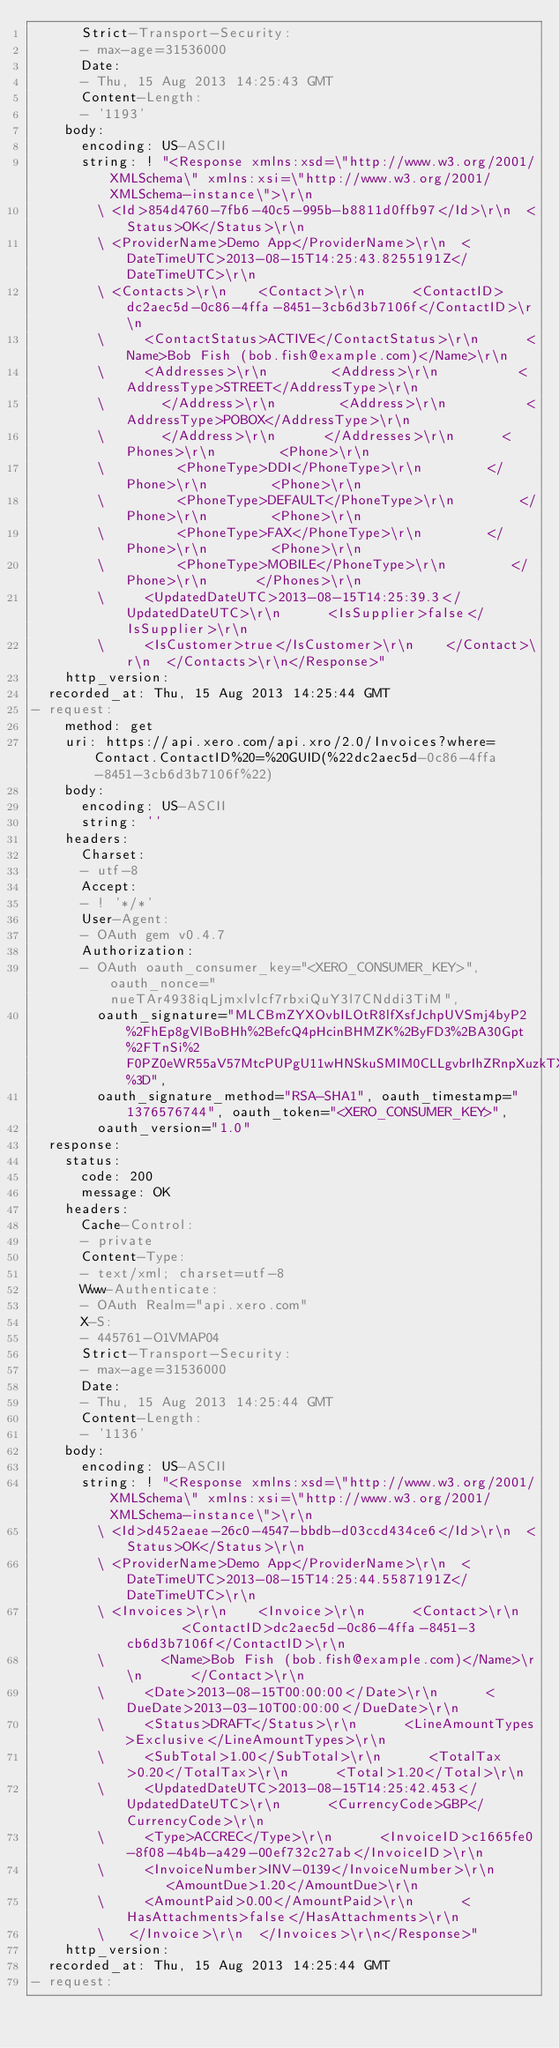Convert code to text. <code><loc_0><loc_0><loc_500><loc_500><_YAML_>      Strict-Transport-Security:
      - max-age=31536000
      Date:
      - Thu, 15 Aug 2013 14:25:43 GMT
      Content-Length:
      - '1193'
    body:
      encoding: US-ASCII
      string: ! "<Response xmlns:xsd=\"http://www.w3.org/2001/XMLSchema\" xmlns:xsi=\"http://www.w3.org/2001/XMLSchema-instance\">\r\n
        \ <Id>854d4760-7fb6-40c5-995b-b8811d0ffb97</Id>\r\n  <Status>OK</Status>\r\n
        \ <ProviderName>Demo App</ProviderName>\r\n  <DateTimeUTC>2013-08-15T14:25:43.8255191Z</DateTimeUTC>\r\n
        \ <Contacts>\r\n    <Contact>\r\n      <ContactID>dc2aec5d-0c86-4ffa-8451-3cb6d3b7106f</ContactID>\r\n
        \     <ContactStatus>ACTIVE</ContactStatus>\r\n      <Name>Bob Fish (bob.fish@example.com)</Name>\r\n
        \     <Addresses>\r\n        <Address>\r\n          <AddressType>STREET</AddressType>\r\n
        \       </Address>\r\n        <Address>\r\n          <AddressType>POBOX</AddressType>\r\n
        \       </Address>\r\n      </Addresses>\r\n      <Phones>\r\n        <Phone>\r\n
        \         <PhoneType>DDI</PhoneType>\r\n        </Phone>\r\n        <Phone>\r\n
        \         <PhoneType>DEFAULT</PhoneType>\r\n        </Phone>\r\n        <Phone>\r\n
        \         <PhoneType>FAX</PhoneType>\r\n        </Phone>\r\n        <Phone>\r\n
        \         <PhoneType>MOBILE</PhoneType>\r\n        </Phone>\r\n      </Phones>\r\n
        \     <UpdatedDateUTC>2013-08-15T14:25:39.3</UpdatedDateUTC>\r\n      <IsSupplier>false</IsSupplier>\r\n
        \     <IsCustomer>true</IsCustomer>\r\n    </Contact>\r\n  </Contacts>\r\n</Response>"
    http_version: 
  recorded_at: Thu, 15 Aug 2013 14:25:44 GMT
- request:
    method: get
    uri: https://api.xero.com/api.xro/2.0/Invoices?where=Contact.ContactID%20=%20GUID(%22dc2aec5d-0c86-4ffa-8451-3cb6d3b7106f%22)
    body:
      encoding: US-ASCII
      string: ''
    headers:
      Charset:
      - utf-8
      Accept:
      - ! '*/*'
      User-Agent:
      - OAuth gem v0.4.7
      Authorization:
      - OAuth oauth_consumer_key="<XERO_CONSUMER_KEY>", oauth_nonce="nueTAr4938iqLjmxlvlcf7rbxiQuY3l7CNddi3TiM",
        oauth_signature="MLCBmZYXOvbILOtR8lfXsfJchpUVSmj4byP2%2FhEp8gVlBoBHh%2BefcQ4pHcinBHMZK%2ByFD3%2BA30Gpt%2FTnSi%2F0PZ0eWR55aV57MtcPUPgU11wHNSkuSMIM0CLLgvbrIhZRnpXuzkTXIocCl6eXOmj4eBXe3AGLmWTMHJT59CfBoeo%3D",
        oauth_signature_method="RSA-SHA1", oauth_timestamp="1376576744", oauth_token="<XERO_CONSUMER_KEY>",
        oauth_version="1.0"
  response:
    status:
      code: 200
      message: OK
    headers:
      Cache-Control:
      - private
      Content-Type:
      - text/xml; charset=utf-8
      Www-Authenticate:
      - OAuth Realm="api.xero.com"
      X-S:
      - 445761-O1VMAP04
      Strict-Transport-Security:
      - max-age=31536000
      Date:
      - Thu, 15 Aug 2013 14:25:44 GMT
      Content-Length:
      - '1136'
    body:
      encoding: US-ASCII
      string: ! "<Response xmlns:xsd=\"http://www.w3.org/2001/XMLSchema\" xmlns:xsi=\"http://www.w3.org/2001/XMLSchema-instance\">\r\n
        \ <Id>d452aeae-26c0-4547-bbdb-d03ccd434ce6</Id>\r\n  <Status>OK</Status>\r\n
        \ <ProviderName>Demo App</ProviderName>\r\n  <DateTimeUTC>2013-08-15T14:25:44.5587191Z</DateTimeUTC>\r\n
        \ <Invoices>\r\n    <Invoice>\r\n      <Contact>\r\n        <ContactID>dc2aec5d-0c86-4ffa-8451-3cb6d3b7106f</ContactID>\r\n
        \       <Name>Bob Fish (bob.fish@example.com)</Name>\r\n      </Contact>\r\n
        \     <Date>2013-08-15T00:00:00</Date>\r\n      <DueDate>2013-03-10T00:00:00</DueDate>\r\n
        \     <Status>DRAFT</Status>\r\n      <LineAmountTypes>Exclusive</LineAmountTypes>\r\n
        \     <SubTotal>1.00</SubTotal>\r\n      <TotalTax>0.20</TotalTax>\r\n      <Total>1.20</Total>\r\n
        \     <UpdatedDateUTC>2013-08-15T14:25:42.453</UpdatedDateUTC>\r\n      <CurrencyCode>GBP</CurrencyCode>\r\n
        \     <Type>ACCREC</Type>\r\n      <InvoiceID>c1665fe0-8f08-4b4b-a429-00ef732c27ab</InvoiceID>\r\n
        \     <InvoiceNumber>INV-0139</InvoiceNumber>\r\n      <AmountDue>1.20</AmountDue>\r\n
        \     <AmountPaid>0.00</AmountPaid>\r\n      <HasAttachments>false</HasAttachments>\r\n
        \   </Invoice>\r\n  </Invoices>\r\n</Response>"
    http_version: 
  recorded_at: Thu, 15 Aug 2013 14:25:44 GMT
- request:</code> 